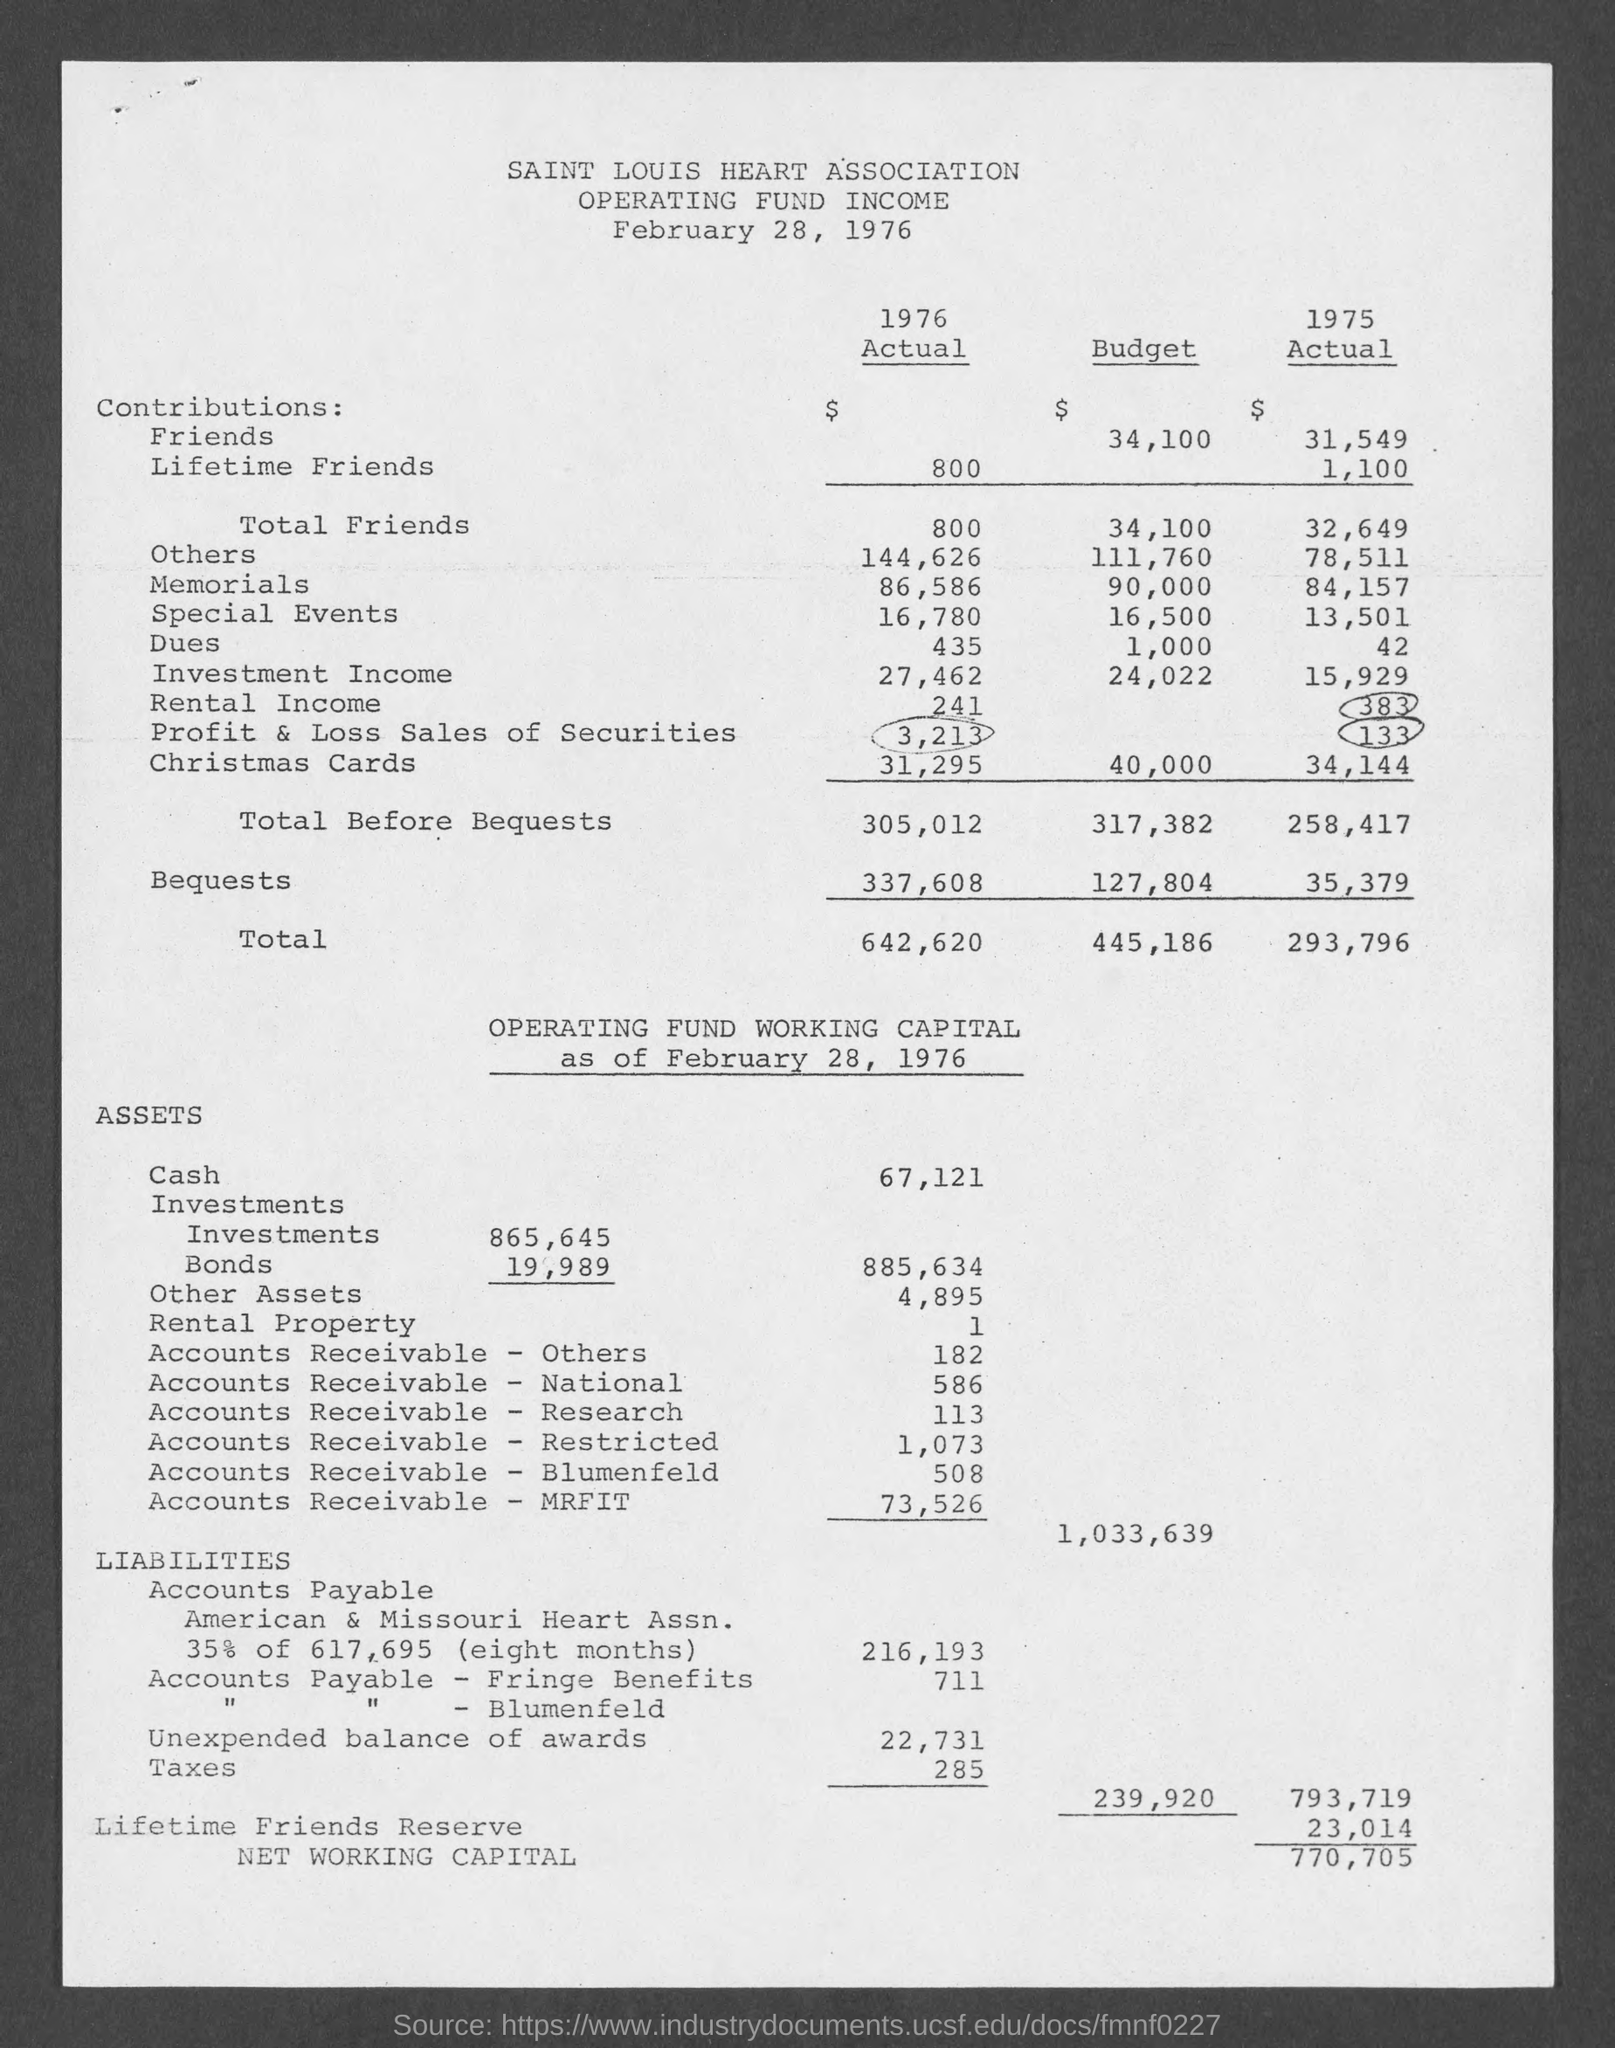Which association is mentioned in the document ?
Offer a very short reply. SAINT LOUIS HEART ASSOCIATION. What is the date on the document?
Offer a very short reply. February 28, 1976. 